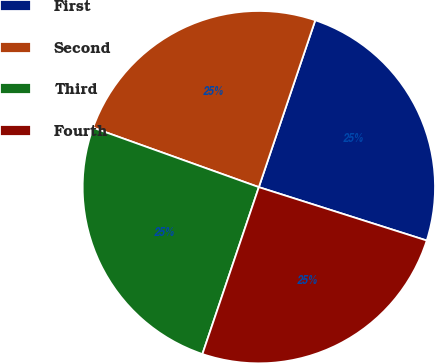<chart> <loc_0><loc_0><loc_500><loc_500><pie_chart><fcel>First<fcel>Second<fcel>Third<fcel>Fourth<nl><fcel>24.71%<fcel>24.71%<fcel>25.29%<fcel>25.29%<nl></chart> 